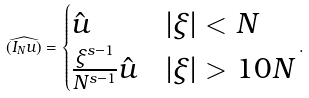Convert formula to latex. <formula><loc_0><loc_0><loc_500><loc_500>\widehat { ( I _ { N } u ) } = \begin{cases} \hat { u } & | \xi | < N \\ \frac { \xi ^ { s - 1 } } { N ^ { s - 1 } } \hat { u } & | \xi | > 1 0 N \end{cases} .</formula> 